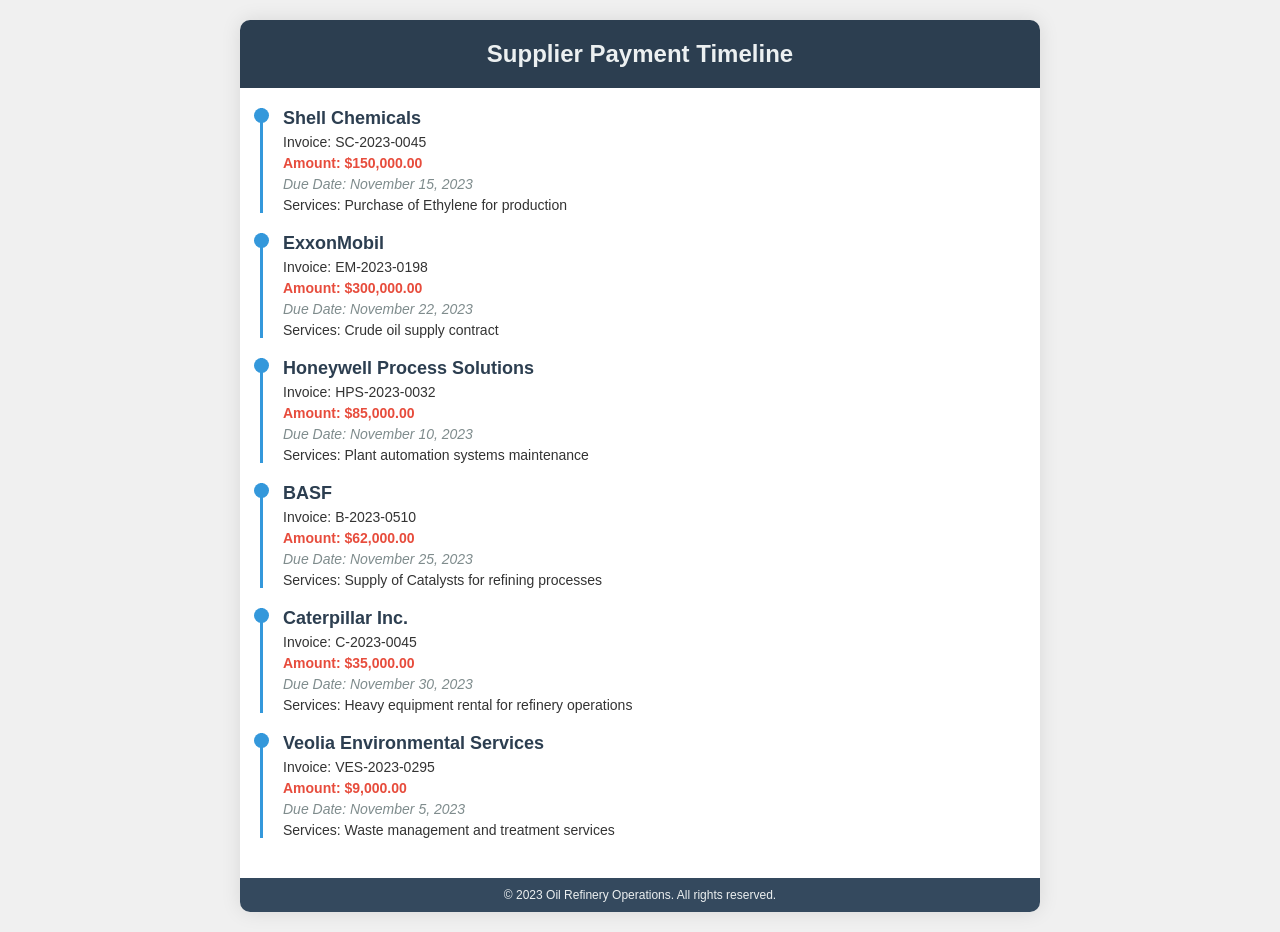What is the total amount due to Shell Chemicals? The total amount due is specified in the invoice details for Shell Chemicals.
Answer: $150,000.00 When is the payment due for Honeywell Process Solutions? The due date for Honeywell Process Solutions is mentioned along with the invoice details.
Answer: November 10, 2023 What services are provided by BASF? The services provided by BASF are listed in the document, detailing what was supplied.
Answer: Supply of Catalysts for refining processes Which supplier has the earliest payment due date? The earliest due date can be determined by reviewing the due dates for each supplier, and Veolia Environmental Services has the earliest.
Answer: November 5, 2023 What is the invoice number for ExxonMobil? The document contains specific invoice numbers for each supplier, and ExxonMobil's invoice number is clearly stated.
Answer: EM-2023-0198 How much is the total amount due for all suppliers combined? The total amount can be calculated by adding all the amounts listed for each supplier.
Answer: $641,000.00 What service is associated with the invoice from Caterpillar Inc.? The service detail for Caterpillar Inc. lists the specific service provided per their invoice.
Answer: Heavy equipment rental for refinery operations Who is responsible for waste management services? The document indicates which supplier is responsible for waste management by mentioning their name and services.
Answer: Veolia Environmental Services 